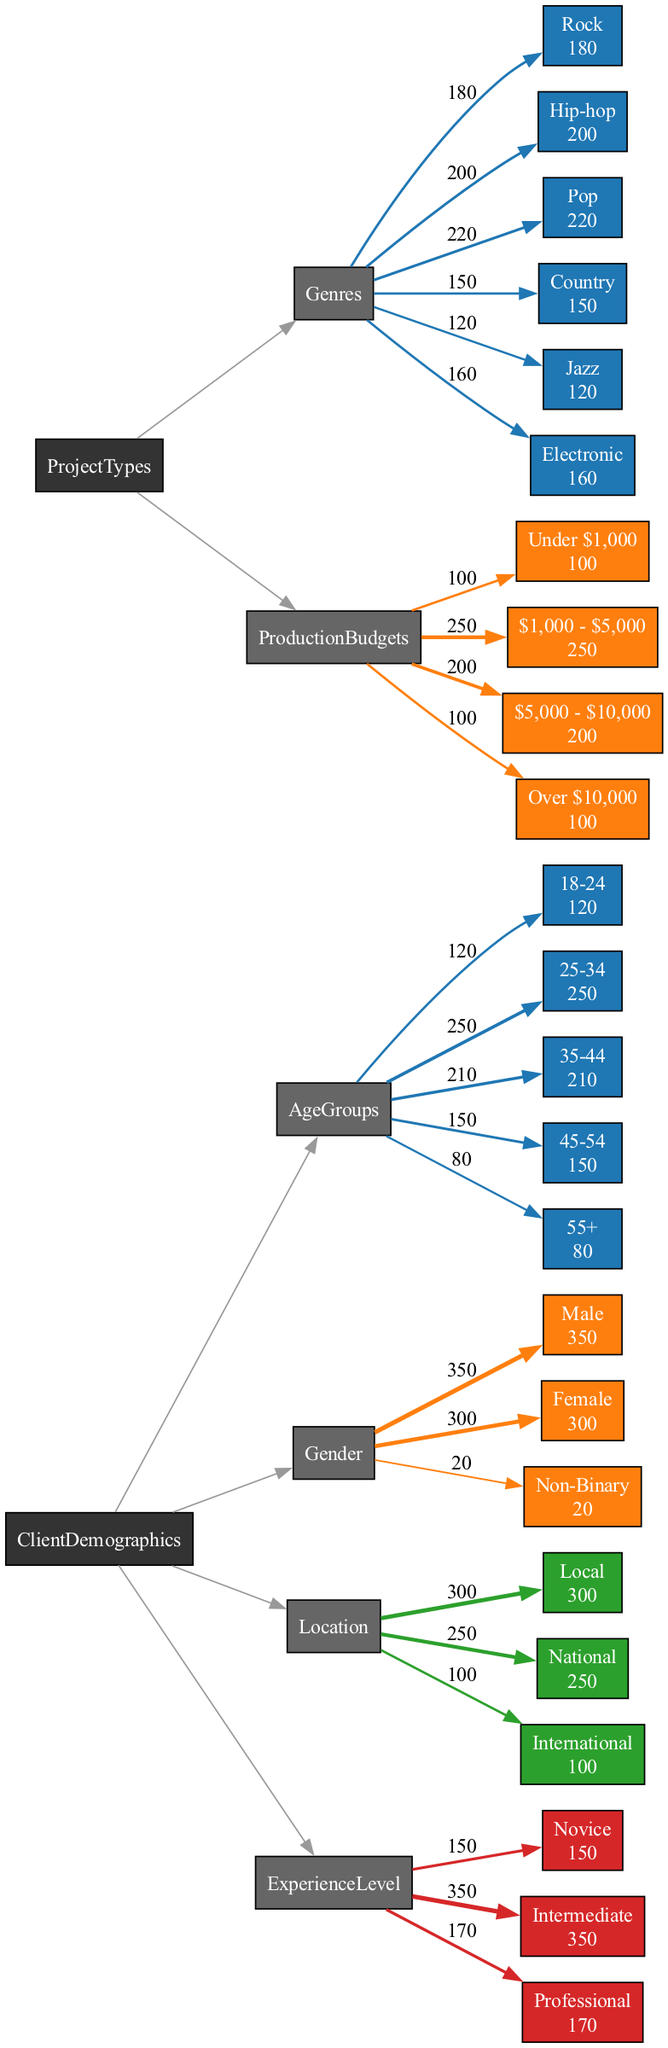What is the most popular age group among clients? By looking at the Age Groups section, the highest value is in the 25-34 group with 250 clients.
Answer: 25-34 What is the total number of female clients? The Gender section indicates there are 300 female clients listed in the diagram.
Answer: 300 Which genre has the highest production budget category? Looking at the Production Budgets, the highest budget category is $1,000 - $5,000 with 250 projects.
Answer: $1,000 - $5,000 How many clients identified as Non-Binary? In the Gender section, there are 20 clients identified as Non-Binary.
Answer: 20 What is the relationship between the Novice experience level and the Rock genre? The Novice experience level has 150 clients overall, while the Rock genre has 180 projects; however, the diagram does not specify a direct relationship between these two.
Answer: No direct relation Which location category has the highest number of clients? The Location section shows that Local clients total 300, which is higher than both National and International categories.
Answer: Local How many project types fall into the "Over $10,000" budget category? The Production Budgets section indicates there are 100 projects in the "Over $10,000" category.
Answer: 100 What percentage of clients are male compared to the total number of clients? To find this, we sum all clients: 350 males + 300 females + 20 Non-Binary = 670 total clients; hence, 350 males represent roughly 52.24%.
Answer: 52.24% Which two genres are most closely linked in terms of project count? Looking at the Genres section, Hip-hop has 200 projects and Pop has 220. They are the two with the most similar counts with a gap of only 20 projects.
Answer: Hip-hop and Pop How does the number of Intermediate clients compare to Professional clients? The Intermediate section shows 350 clients, while Professional has 170 clients; thus, there are 180 more Intermediate clients than Professional ones.
Answer: 180 more Intermediate clients 